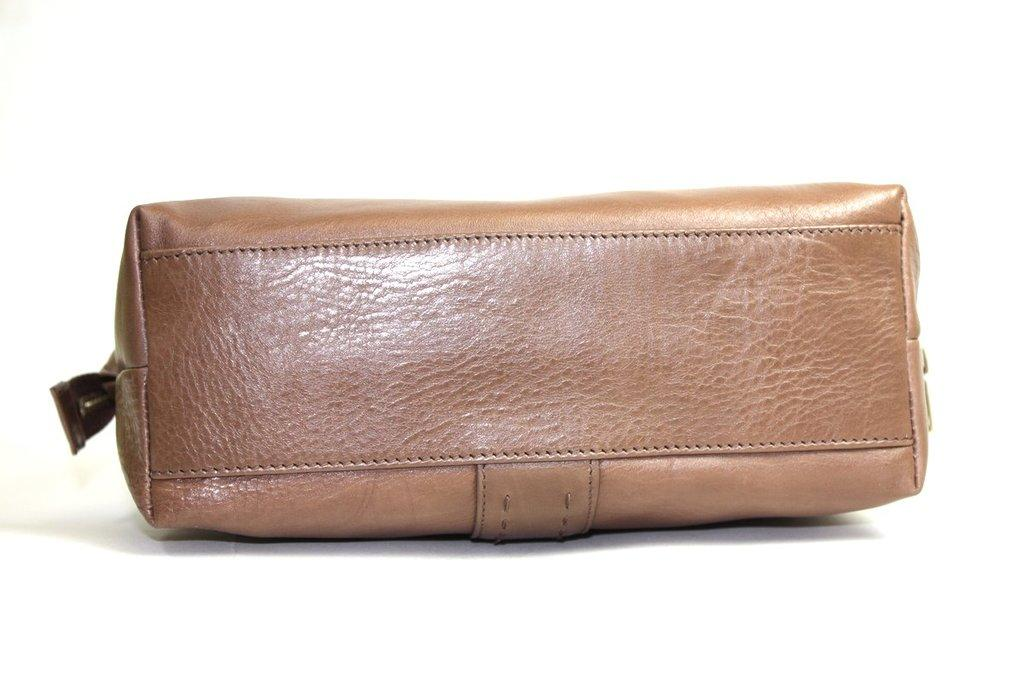What object can be seen in the image? There is a bag in the image. What color is the bag? The bag is colored brown. What type of creature is cooking on the stove in the image? There is no stove or creature present in the image; it only features a brown bag. 